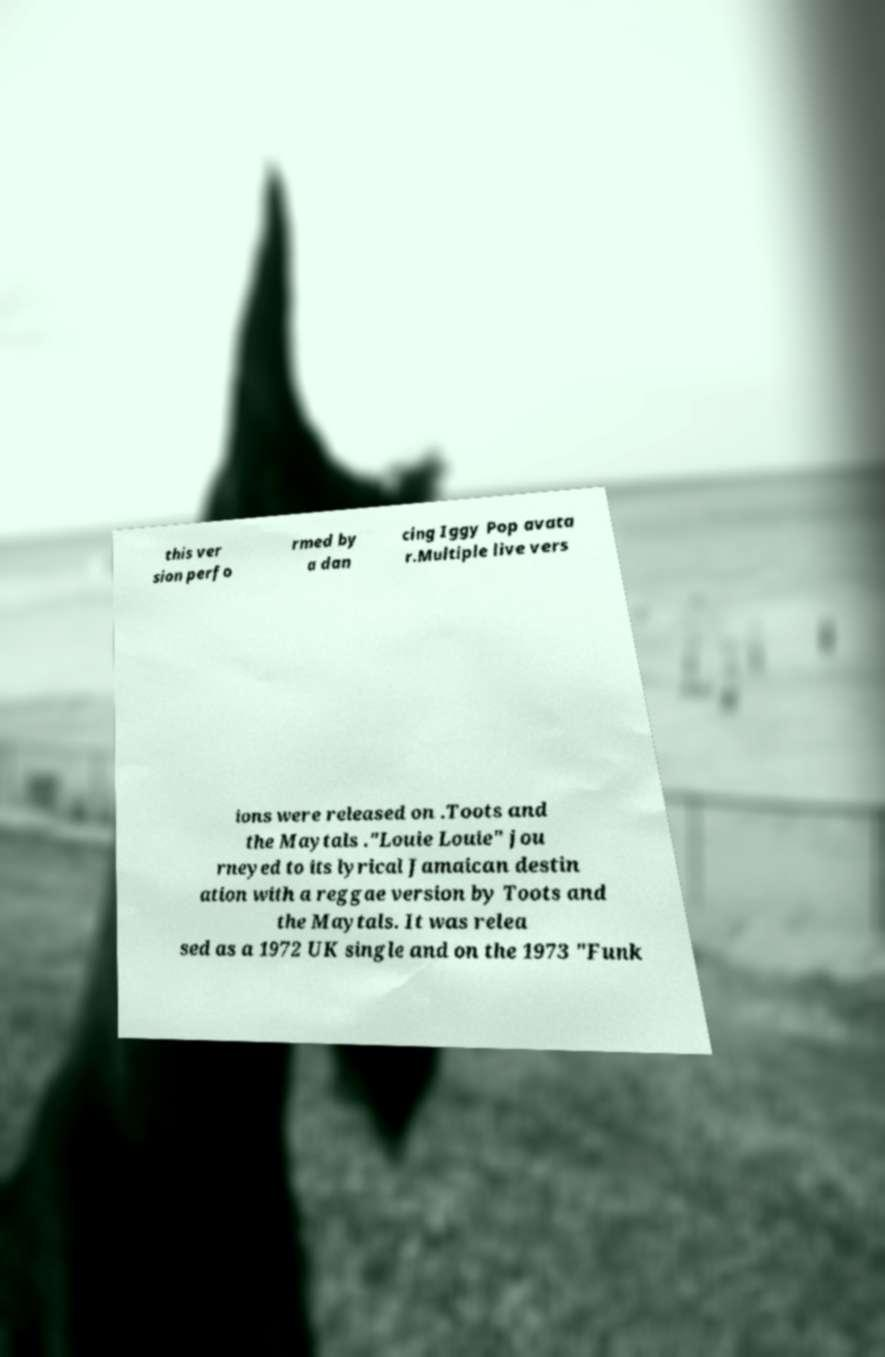Could you extract and type out the text from this image? this ver sion perfo rmed by a dan cing Iggy Pop avata r.Multiple live vers ions were released on .Toots and the Maytals ."Louie Louie" jou rneyed to its lyrical Jamaican destin ation with a reggae version by Toots and the Maytals. It was relea sed as a 1972 UK single and on the 1973 "Funk 